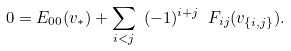<formula> <loc_0><loc_0><loc_500><loc_500>0 = E _ { 0 0 } ( v _ { * } ) + \sum _ { i < j } \ ( - 1 ) ^ { i + j } \ F _ { i j } ( v _ { \{ i , j \} } ) .</formula> 